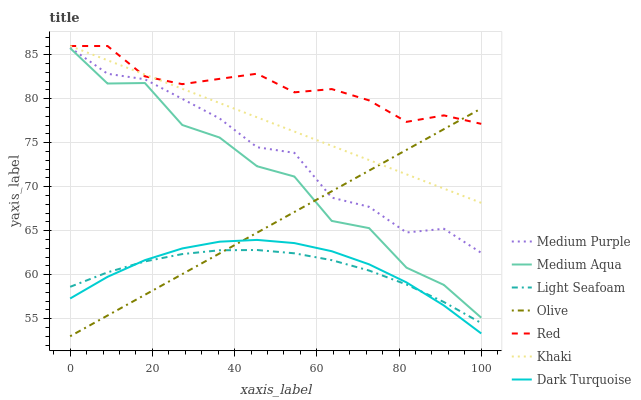Does Light Seafoam have the minimum area under the curve?
Answer yes or no. Yes. Does Red have the maximum area under the curve?
Answer yes or no. Yes. Does Dark Turquoise have the minimum area under the curve?
Answer yes or no. No. Does Dark Turquoise have the maximum area under the curve?
Answer yes or no. No. Is Khaki the smoothest?
Answer yes or no. Yes. Is Medium Aqua the roughest?
Answer yes or no. Yes. Is Dark Turquoise the smoothest?
Answer yes or no. No. Is Dark Turquoise the roughest?
Answer yes or no. No. Does Olive have the lowest value?
Answer yes or no. Yes. Does Dark Turquoise have the lowest value?
Answer yes or no. No. Does Red have the highest value?
Answer yes or no. Yes. Does Dark Turquoise have the highest value?
Answer yes or no. No. Is Dark Turquoise less than Medium Aqua?
Answer yes or no. Yes. Is Medium Aqua greater than Light Seafoam?
Answer yes or no. Yes. Does Olive intersect Medium Aqua?
Answer yes or no. Yes. Is Olive less than Medium Aqua?
Answer yes or no. No. Is Olive greater than Medium Aqua?
Answer yes or no. No. Does Dark Turquoise intersect Medium Aqua?
Answer yes or no. No. 